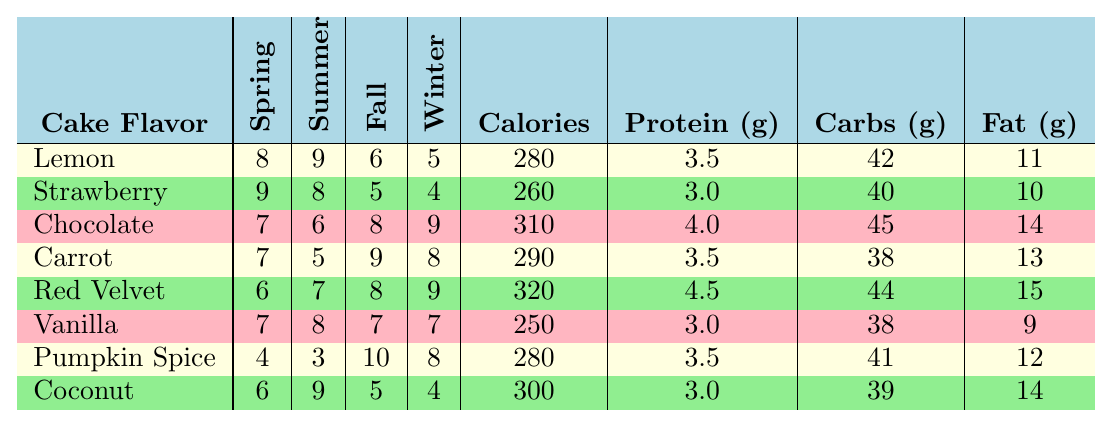What is the most popular cake flavor in Spring? Looking at the Spring column, the highest value of popularity is 9, which corresponds to Strawberry.
Answer: Strawberry Which cake flavor has the highest calorie count? Comparing the calorie values, Chocolate has the highest calories at 310.
Answer: Chocolate What is the average protein content for all cake flavors? The protein contents are 3.5, 3.0, 4.0, 3.5, 4.5, 3.0, 3.5, and 3.0. Summing these gives 25.0, and there are 8 flavors, so the average is 25.0/8 = 3.125.
Answer: 3.125 How popular is Vanilla in the Fall? In the Fall column, Vanilla has a popularity score of 7.
Answer: 7 What is the difference in popularity between Chocolate in Winter and Pumpkin Spice in Fall? Chocolate's popularity in Winter is 9 and Pumpkin Spice in Fall is 10. The difference is 10 - 9 = 1.
Answer: 1 Which cake flavors are more popular than 8 in Summer? Looking at the Summer column, the flavors Lemon (9), Strawberry (8), and Coconut (9) are all greater than or equal to 8.
Answer: Lemon, Strawberry, Coconut Is Carrot the second most popular cake in Winter? In Winter, Carrot has a popularity of 8, while Red Velvet has 9, making Carrot the third most popular.
Answer: No What is the total amount of carbs in Coconut and Vanilla combined? Coconut has 39 grams of carbs, and Vanilla has 38 grams. Adding these gives 39 + 38 = 77 grams.
Answer: 77 Which cake flavor has the lowest popularity in Winter? Checking the Winter column, Pumpkin Spice has the lowest popularity score of 8.
Answer: Pumpkin Spice How does the fat content of Red Velvet compare to that of Lemon? Red Velvet has 15 grams of fat, while Lemon has 11 grams. The comparison shows Red Velvet has more fat by 4 grams (15 - 11 = 4).
Answer: 4 grams more What are the average popularity scores across all the cakes in Fall? Adding the Fall popularity scores (6 + 5 + 8 + 9 + 8 + 7 + 10 + 5 = 58) and dividing by 8 gives an average of 7.25.
Answer: 7.25 